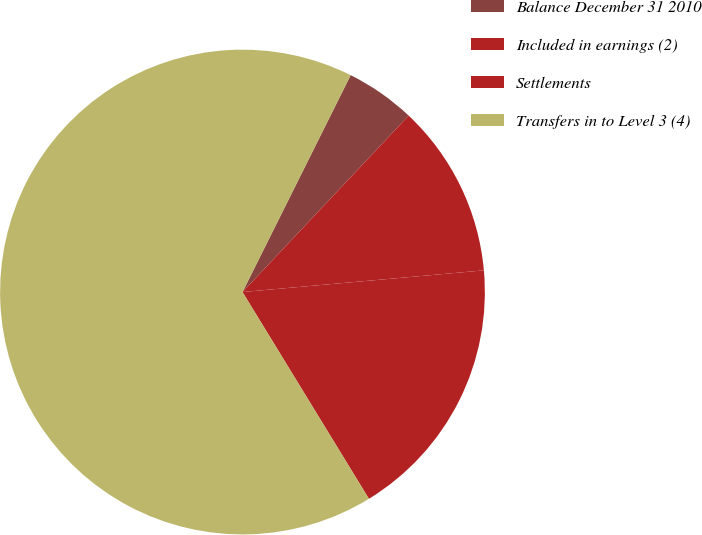Convert chart to OTSL. <chart><loc_0><loc_0><loc_500><loc_500><pie_chart><fcel>Balance December 31 2010<fcel>Included in earnings (2)<fcel>Settlements<fcel>Transfers in to Level 3 (4)<nl><fcel>4.66%<fcel>11.55%<fcel>17.69%<fcel>66.1%<nl></chart> 